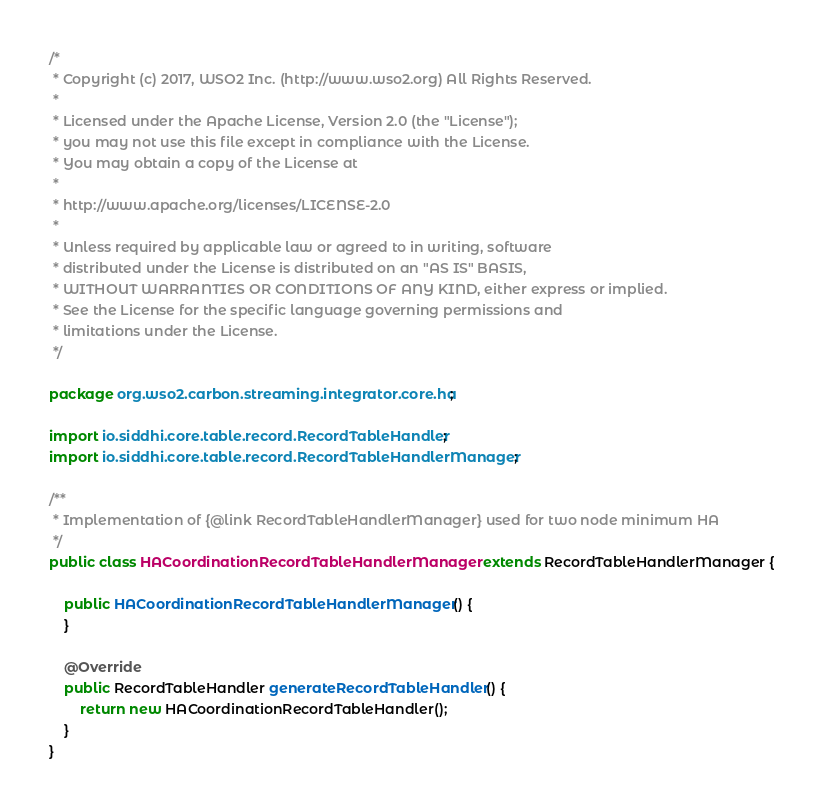<code> <loc_0><loc_0><loc_500><loc_500><_Java_>/*
 * Copyright (c) 2017, WSO2 Inc. (http://www.wso2.org) All Rights Reserved.
 *
 * Licensed under the Apache License, Version 2.0 (the "License");
 * you may not use this file except in compliance with the License.
 * You may obtain a copy of the License at
 *
 * http://www.apache.org/licenses/LICENSE-2.0
 *
 * Unless required by applicable law or agreed to in writing, software
 * distributed under the License is distributed on an "AS IS" BASIS,
 * WITHOUT WARRANTIES OR CONDITIONS OF ANY KIND, either express or implied.
 * See the License for the specific language governing permissions and
 * limitations under the License.
 */

package org.wso2.carbon.streaming.integrator.core.ha;

import io.siddhi.core.table.record.RecordTableHandler;
import io.siddhi.core.table.record.RecordTableHandlerManager;

/**
 * Implementation of {@link RecordTableHandlerManager} used for two node minimum HA
 */
public class HACoordinationRecordTableHandlerManager extends RecordTableHandlerManager {

    public HACoordinationRecordTableHandlerManager() {
    }

    @Override
    public RecordTableHandler generateRecordTableHandler() {
        return new HACoordinationRecordTableHandler();
    }
}
</code> 